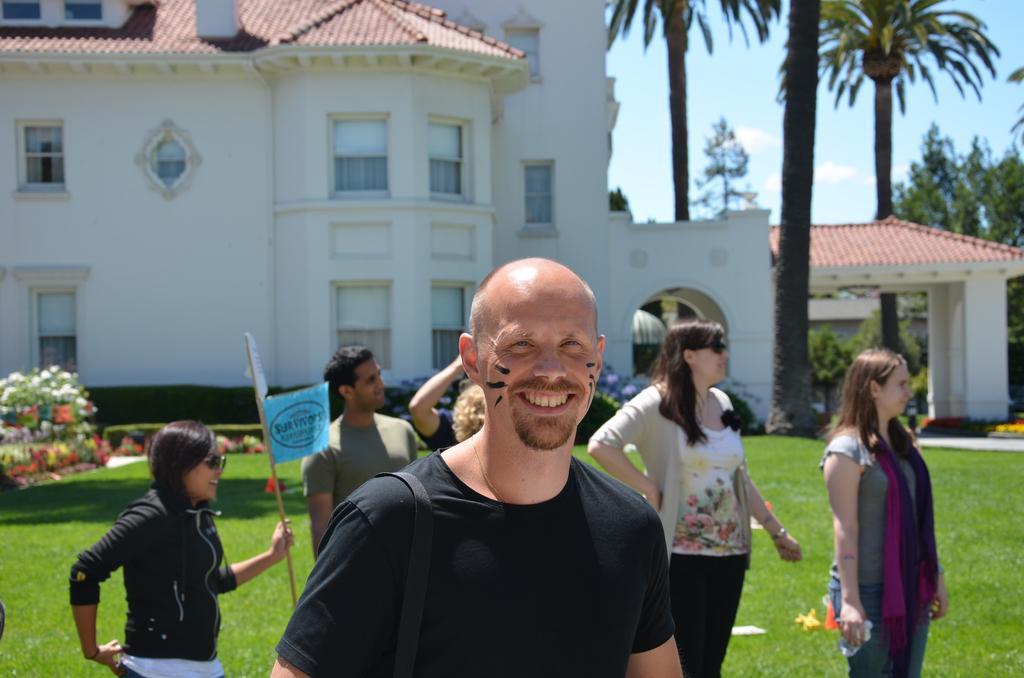How would you summarize this image in a sentence or two? In this image I can see the group of people standing and wearing the different color dresses. I can see one person is holding the stick and there is a paper to that. To the left I can see many flowers which are in white, green, yellow and red. In the background I can see the house and to the right there are many trees, clouds and the blue sky. 